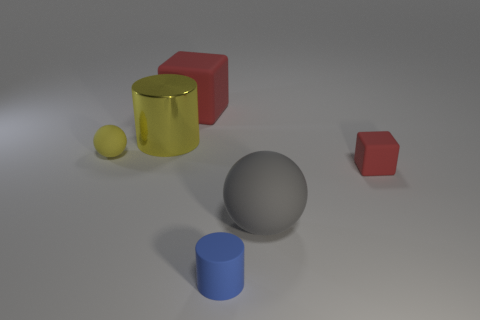What number of big purple cylinders are there?
Provide a short and direct response. 0. There is a matte object that is on the left side of the metallic object; is its color the same as the cylinder behind the yellow ball?
Provide a succinct answer. Yes. What size is the cylinder that is the same color as the small rubber ball?
Offer a very short reply. Large. There is a matte cube behind the tiny red rubber block; what color is it?
Provide a short and direct response. Red. Are the object in front of the large gray object and the tiny red block made of the same material?
Keep it short and to the point. Yes. How many objects are on the right side of the yellow metal cylinder and behind the tiny red matte thing?
Your answer should be very brief. 1. What is the color of the cylinder that is right of the rubber cube that is behind the rubber ball on the left side of the large red block?
Your response must be concise. Blue. How many other things are there of the same shape as the small red matte thing?
Provide a short and direct response. 1. Is there a big yellow cylinder that is in front of the yellow thing in front of the yellow shiny thing?
Provide a succinct answer. No. How many metal things are yellow cubes or large objects?
Give a very brief answer. 1. 